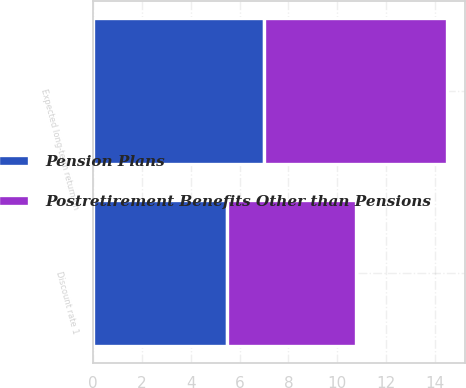Convert chart to OTSL. <chart><loc_0><loc_0><loc_500><loc_500><stacked_bar_chart><ecel><fcel>Discount rate 1<fcel>Expected long-term return on<nl><fcel>Postretirement Benefits Other than Pensions<fcel>5.25<fcel>7.5<nl><fcel>Pension Plans<fcel>5.5<fcel>7<nl></chart> 